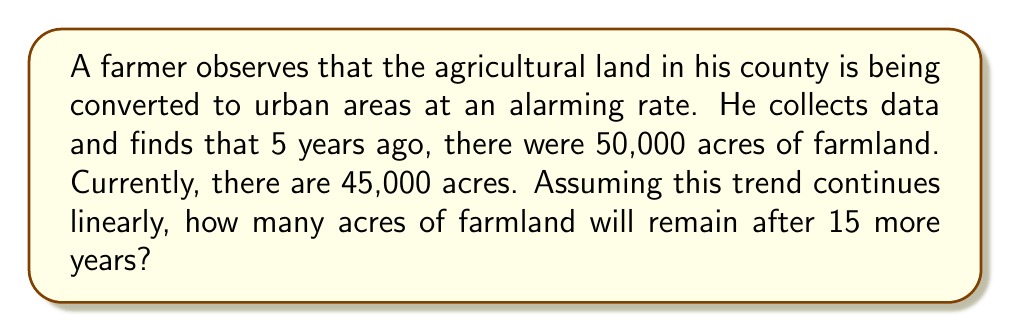Solve this math problem. Let's approach this problem step-by-step using a linear equation:

1) Let $y$ represent the amount of farmland in acres and $x$ represent the number of years passed.

2) We can form a linear equation in the form $y = mx + b$, where $m$ is the slope (rate of change) and $b$ is the y-intercept.

3) We have two points:
   $(0, 45000)$ - current situation
   $(-5, 50000)$ - situation 5 years ago

4) Calculate the slope:
   $m = \frac{y_2 - y_1}{x_2 - x_1} = \frac{45000 - 50000}{0 - (-5)} = \frac{-5000}{5} = -1000$

   This means the farm is losing 1000 acres per year.

5) Now we can form our equation using the point-slope form:
   $y - y_1 = m(x - x_1)$
   $y - 45000 = -1000(x - 0)$
   $y = -1000x + 45000$

6) To find the amount of farmland after 15 more years, we substitute $x = 15$:
   $y = -1000(15) + 45000 = -15000 + 45000 = 30000$

Therefore, after 15 more years, there will be 30,000 acres of farmland remaining.
Answer: 30,000 acres 